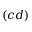Convert formula to latex. <formula><loc_0><loc_0><loc_500><loc_500>( c d )</formula> 